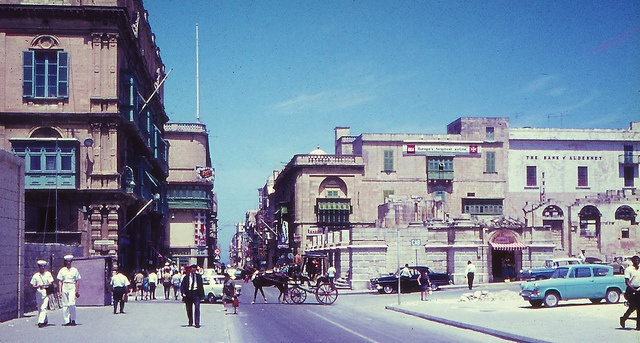Describe the objects in this image and their specific colors. I can see car in darkgray, lightblue, and blue tones, people in darkgray, beige, gray, and purple tones, car in darkgray, black, navy, purple, and blue tones, car in darkgray, beige, black, and purple tones, and people in darkgray, black, navy, ivory, and purple tones in this image. 